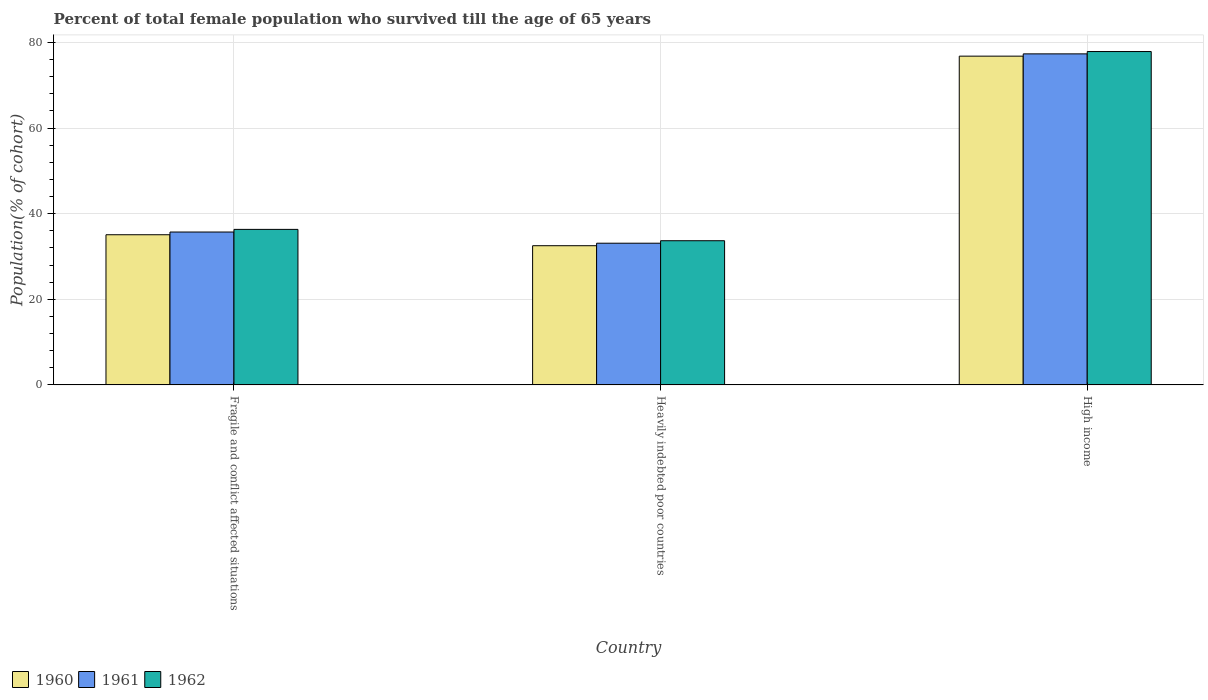How many different coloured bars are there?
Give a very brief answer. 3. Are the number of bars per tick equal to the number of legend labels?
Your answer should be very brief. Yes. Are the number of bars on each tick of the X-axis equal?
Offer a terse response. Yes. How many bars are there on the 2nd tick from the right?
Make the answer very short. 3. What is the label of the 3rd group of bars from the left?
Your answer should be very brief. High income. In how many cases, is the number of bars for a given country not equal to the number of legend labels?
Ensure brevity in your answer.  0. What is the percentage of total female population who survived till the age of 65 years in 1962 in Fragile and conflict affected situations?
Offer a terse response. 36.34. Across all countries, what is the maximum percentage of total female population who survived till the age of 65 years in 1961?
Ensure brevity in your answer.  77.34. Across all countries, what is the minimum percentage of total female population who survived till the age of 65 years in 1961?
Your answer should be very brief. 33.1. In which country was the percentage of total female population who survived till the age of 65 years in 1962 maximum?
Ensure brevity in your answer.  High income. In which country was the percentage of total female population who survived till the age of 65 years in 1961 minimum?
Provide a succinct answer. Heavily indebted poor countries. What is the total percentage of total female population who survived till the age of 65 years in 1960 in the graph?
Provide a succinct answer. 144.41. What is the difference between the percentage of total female population who survived till the age of 65 years in 1961 in Heavily indebted poor countries and that in High income?
Make the answer very short. -44.24. What is the difference between the percentage of total female population who survived till the age of 65 years in 1960 in Fragile and conflict affected situations and the percentage of total female population who survived till the age of 65 years in 1962 in High income?
Provide a short and direct response. -42.8. What is the average percentage of total female population who survived till the age of 65 years in 1961 per country?
Your response must be concise. 48.72. What is the difference between the percentage of total female population who survived till the age of 65 years of/in 1962 and percentage of total female population who survived till the age of 65 years of/in 1961 in Heavily indebted poor countries?
Provide a succinct answer. 0.58. In how many countries, is the percentage of total female population who survived till the age of 65 years in 1962 greater than 68 %?
Offer a terse response. 1. What is the ratio of the percentage of total female population who survived till the age of 65 years in 1962 in Fragile and conflict affected situations to that in Heavily indebted poor countries?
Provide a succinct answer. 1.08. Is the percentage of total female population who survived till the age of 65 years in 1962 in Fragile and conflict affected situations less than that in Heavily indebted poor countries?
Your answer should be compact. No. Is the difference between the percentage of total female population who survived till the age of 65 years in 1962 in Fragile and conflict affected situations and High income greater than the difference between the percentage of total female population who survived till the age of 65 years in 1961 in Fragile and conflict affected situations and High income?
Give a very brief answer. Yes. What is the difference between the highest and the second highest percentage of total female population who survived till the age of 65 years in 1961?
Ensure brevity in your answer.  -2.61. What is the difference between the highest and the lowest percentage of total female population who survived till the age of 65 years in 1960?
Keep it short and to the point. 44.29. What does the 1st bar from the left in High income represents?
Offer a very short reply. 1960. How many bars are there?
Give a very brief answer. 9. Are all the bars in the graph horizontal?
Make the answer very short. No. Are the values on the major ticks of Y-axis written in scientific E-notation?
Your answer should be very brief. No. Does the graph contain any zero values?
Provide a succinct answer. No. How are the legend labels stacked?
Give a very brief answer. Horizontal. What is the title of the graph?
Keep it short and to the point. Percent of total female population who survived till the age of 65 years. Does "2008" appear as one of the legend labels in the graph?
Offer a very short reply. No. What is the label or title of the Y-axis?
Ensure brevity in your answer.  Population(% of cohort). What is the Population(% of cohort) in 1960 in Fragile and conflict affected situations?
Keep it short and to the point. 35.08. What is the Population(% of cohort) of 1961 in Fragile and conflict affected situations?
Offer a very short reply. 35.72. What is the Population(% of cohort) in 1962 in Fragile and conflict affected situations?
Make the answer very short. 36.34. What is the Population(% of cohort) of 1960 in Heavily indebted poor countries?
Provide a succinct answer. 32.52. What is the Population(% of cohort) of 1961 in Heavily indebted poor countries?
Your answer should be compact. 33.1. What is the Population(% of cohort) in 1962 in Heavily indebted poor countries?
Ensure brevity in your answer.  33.69. What is the Population(% of cohort) in 1960 in High income?
Provide a succinct answer. 76.81. What is the Population(% of cohort) of 1961 in High income?
Your answer should be very brief. 77.34. What is the Population(% of cohort) of 1962 in High income?
Make the answer very short. 77.88. Across all countries, what is the maximum Population(% of cohort) of 1960?
Keep it short and to the point. 76.81. Across all countries, what is the maximum Population(% of cohort) of 1961?
Your answer should be very brief. 77.34. Across all countries, what is the maximum Population(% of cohort) in 1962?
Your response must be concise. 77.88. Across all countries, what is the minimum Population(% of cohort) of 1960?
Give a very brief answer. 32.52. Across all countries, what is the minimum Population(% of cohort) of 1961?
Ensure brevity in your answer.  33.1. Across all countries, what is the minimum Population(% of cohort) of 1962?
Provide a succinct answer. 33.69. What is the total Population(% of cohort) in 1960 in the graph?
Make the answer very short. 144.41. What is the total Population(% of cohort) in 1961 in the graph?
Offer a terse response. 146.17. What is the total Population(% of cohort) in 1962 in the graph?
Your response must be concise. 147.91. What is the difference between the Population(% of cohort) in 1960 in Fragile and conflict affected situations and that in Heavily indebted poor countries?
Make the answer very short. 2.56. What is the difference between the Population(% of cohort) of 1961 in Fragile and conflict affected situations and that in Heavily indebted poor countries?
Offer a very short reply. 2.61. What is the difference between the Population(% of cohort) in 1962 in Fragile and conflict affected situations and that in Heavily indebted poor countries?
Offer a terse response. 2.65. What is the difference between the Population(% of cohort) in 1960 in Fragile and conflict affected situations and that in High income?
Give a very brief answer. -41.73. What is the difference between the Population(% of cohort) of 1961 in Fragile and conflict affected situations and that in High income?
Keep it short and to the point. -41.62. What is the difference between the Population(% of cohort) of 1962 in Fragile and conflict affected situations and that in High income?
Provide a succinct answer. -41.55. What is the difference between the Population(% of cohort) in 1960 in Heavily indebted poor countries and that in High income?
Keep it short and to the point. -44.29. What is the difference between the Population(% of cohort) of 1961 in Heavily indebted poor countries and that in High income?
Your response must be concise. -44.24. What is the difference between the Population(% of cohort) in 1962 in Heavily indebted poor countries and that in High income?
Your answer should be compact. -44.2. What is the difference between the Population(% of cohort) of 1960 in Fragile and conflict affected situations and the Population(% of cohort) of 1961 in Heavily indebted poor countries?
Offer a terse response. 1.98. What is the difference between the Population(% of cohort) of 1960 in Fragile and conflict affected situations and the Population(% of cohort) of 1962 in Heavily indebted poor countries?
Ensure brevity in your answer.  1.4. What is the difference between the Population(% of cohort) in 1961 in Fragile and conflict affected situations and the Population(% of cohort) in 1962 in Heavily indebted poor countries?
Offer a very short reply. 2.03. What is the difference between the Population(% of cohort) in 1960 in Fragile and conflict affected situations and the Population(% of cohort) in 1961 in High income?
Provide a short and direct response. -42.26. What is the difference between the Population(% of cohort) in 1960 in Fragile and conflict affected situations and the Population(% of cohort) in 1962 in High income?
Offer a very short reply. -42.8. What is the difference between the Population(% of cohort) of 1961 in Fragile and conflict affected situations and the Population(% of cohort) of 1962 in High income?
Your answer should be compact. -42.17. What is the difference between the Population(% of cohort) of 1960 in Heavily indebted poor countries and the Population(% of cohort) of 1961 in High income?
Your response must be concise. -44.82. What is the difference between the Population(% of cohort) in 1960 in Heavily indebted poor countries and the Population(% of cohort) in 1962 in High income?
Provide a succinct answer. -45.36. What is the difference between the Population(% of cohort) of 1961 in Heavily indebted poor countries and the Population(% of cohort) of 1962 in High income?
Give a very brief answer. -44.78. What is the average Population(% of cohort) in 1960 per country?
Keep it short and to the point. 48.14. What is the average Population(% of cohort) of 1961 per country?
Provide a short and direct response. 48.72. What is the average Population(% of cohort) of 1962 per country?
Provide a short and direct response. 49.3. What is the difference between the Population(% of cohort) in 1960 and Population(% of cohort) in 1961 in Fragile and conflict affected situations?
Your response must be concise. -0.63. What is the difference between the Population(% of cohort) of 1960 and Population(% of cohort) of 1962 in Fragile and conflict affected situations?
Keep it short and to the point. -1.25. What is the difference between the Population(% of cohort) of 1961 and Population(% of cohort) of 1962 in Fragile and conflict affected situations?
Give a very brief answer. -0.62. What is the difference between the Population(% of cohort) of 1960 and Population(% of cohort) of 1961 in Heavily indebted poor countries?
Provide a short and direct response. -0.58. What is the difference between the Population(% of cohort) of 1960 and Population(% of cohort) of 1962 in Heavily indebted poor countries?
Provide a succinct answer. -1.17. What is the difference between the Population(% of cohort) of 1961 and Population(% of cohort) of 1962 in Heavily indebted poor countries?
Provide a succinct answer. -0.58. What is the difference between the Population(% of cohort) in 1960 and Population(% of cohort) in 1961 in High income?
Offer a terse response. -0.53. What is the difference between the Population(% of cohort) in 1960 and Population(% of cohort) in 1962 in High income?
Offer a very short reply. -1.07. What is the difference between the Population(% of cohort) of 1961 and Population(% of cohort) of 1962 in High income?
Ensure brevity in your answer.  -0.54. What is the ratio of the Population(% of cohort) in 1960 in Fragile and conflict affected situations to that in Heavily indebted poor countries?
Provide a short and direct response. 1.08. What is the ratio of the Population(% of cohort) in 1961 in Fragile and conflict affected situations to that in Heavily indebted poor countries?
Give a very brief answer. 1.08. What is the ratio of the Population(% of cohort) in 1962 in Fragile and conflict affected situations to that in Heavily indebted poor countries?
Make the answer very short. 1.08. What is the ratio of the Population(% of cohort) in 1960 in Fragile and conflict affected situations to that in High income?
Your answer should be very brief. 0.46. What is the ratio of the Population(% of cohort) of 1961 in Fragile and conflict affected situations to that in High income?
Provide a short and direct response. 0.46. What is the ratio of the Population(% of cohort) in 1962 in Fragile and conflict affected situations to that in High income?
Ensure brevity in your answer.  0.47. What is the ratio of the Population(% of cohort) in 1960 in Heavily indebted poor countries to that in High income?
Offer a very short reply. 0.42. What is the ratio of the Population(% of cohort) in 1961 in Heavily indebted poor countries to that in High income?
Ensure brevity in your answer.  0.43. What is the ratio of the Population(% of cohort) of 1962 in Heavily indebted poor countries to that in High income?
Keep it short and to the point. 0.43. What is the difference between the highest and the second highest Population(% of cohort) in 1960?
Make the answer very short. 41.73. What is the difference between the highest and the second highest Population(% of cohort) of 1961?
Ensure brevity in your answer.  41.62. What is the difference between the highest and the second highest Population(% of cohort) in 1962?
Offer a very short reply. 41.55. What is the difference between the highest and the lowest Population(% of cohort) of 1960?
Ensure brevity in your answer.  44.29. What is the difference between the highest and the lowest Population(% of cohort) of 1961?
Your response must be concise. 44.24. What is the difference between the highest and the lowest Population(% of cohort) of 1962?
Give a very brief answer. 44.2. 